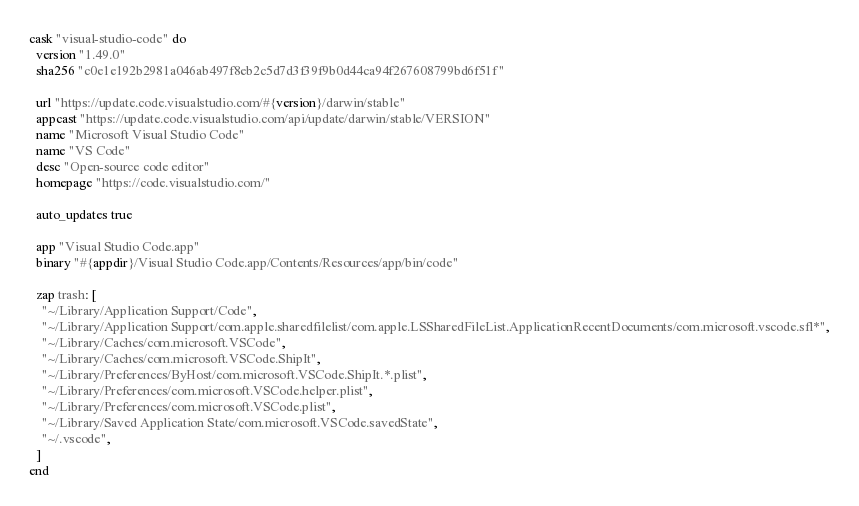<code> <loc_0><loc_0><loc_500><loc_500><_Ruby_>cask "visual-studio-code" do
  version "1.49.0"
  sha256 "c0e1e192b2981a046ab497f8eb2c5d7d3f39f9b0d44ca94f267608799bd6f51f"

  url "https://update.code.visualstudio.com/#{version}/darwin/stable"
  appcast "https://update.code.visualstudio.com/api/update/darwin/stable/VERSION"
  name "Microsoft Visual Studio Code"
  name "VS Code"
  desc "Open-source code editor"
  homepage "https://code.visualstudio.com/"

  auto_updates true

  app "Visual Studio Code.app"
  binary "#{appdir}/Visual Studio Code.app/Contents/Resources/app/bin/code"

  zap trash: [
    "~/Library/Application Support/Code",
    "~/Library/Application Support/com.apple.sharedfilelist/com.apple.LSSharedFileList.ApplicationRecentDocuments/com.microsoft.vscode.sfl*",
    "~/Library/Caches/com.microsoft.VSCode",
    "~/Library/Caches/com.microsoft.VSCode.ShipIt",
    "~/Library/Preferences/ByHost/com.microsoft.VSCode.ShipIt.*.plist",
    "~/Library/Preferences/com.microsoft.VSCode.helper.plist",
    "~/Library/Preferences/com.microsoft.VSCode.plist",
    "~/Library/Saved Application State/com.microsoft.VSCode.savedState",
    "~/.vscode",
  ]
end
</code> 